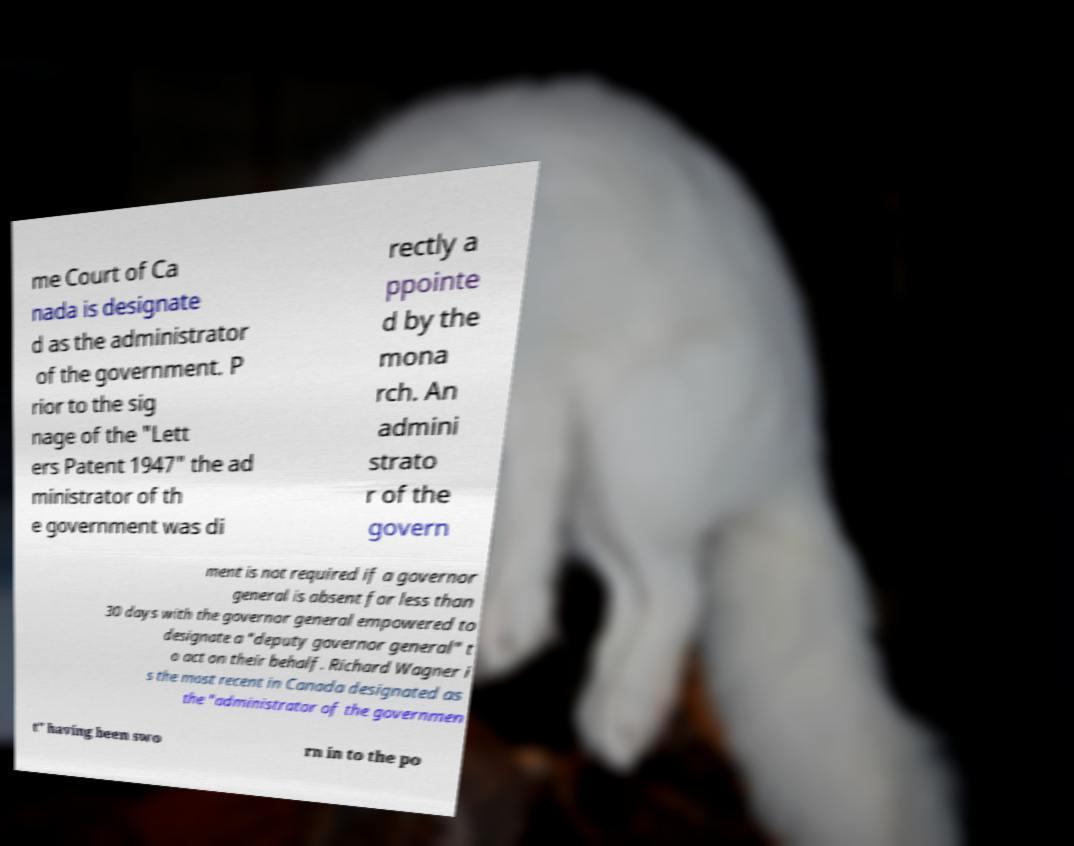Could you assist in decoding the text presented in this image and type it out clearly? me Court of Ca nada is designate d as the administrator of the government. P rior to the sig nage of the "Lett ers Patent 1947" the ad ministrator of th e government was di rectly a ppointe d by the mona rch. An admini strato r of the govern ment is not required if a governor general is absent for less than 30 days with the governor general empowered to designate a "deputy governor general" t o act on their behalf. Richard Wagner i s the most recent in Canada designated as the "administrator of the governmen t" having been swo rn in to the po 